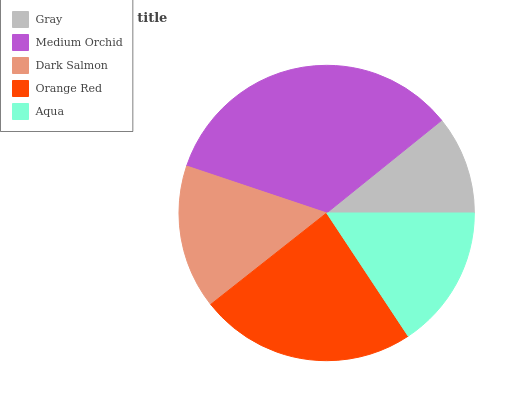Is Gray the minimum?
Answer yes or no. Yes. Is Medium Orchid the maximum?
Answer yes or no. Yes. Is Dark Salmon the minimum?
Answer yes or no. No. Is Dark Salmon the maximum?
Answer yes or no. No. Is Medium Orchid greater than Dark Salmon?
Answer yes or no. Yes. Is Dark Salmon less than Medium Orchid?
Answer yes or no. Yes. Is Dark Salmon greater than Medium Orchid?
Answer yes or no. No. Is Medium Orchid less than Dark Salmon?
Answer yes or no. No. Is Dark Salmon the high median?
Answer yes or no. Yes. Is Dark Salmon the low median?
Answer yes or no. Yes. Is Gray the high median?
Answer yes or no. No. Is Aqua the low median?
Answer yes or no. No. 